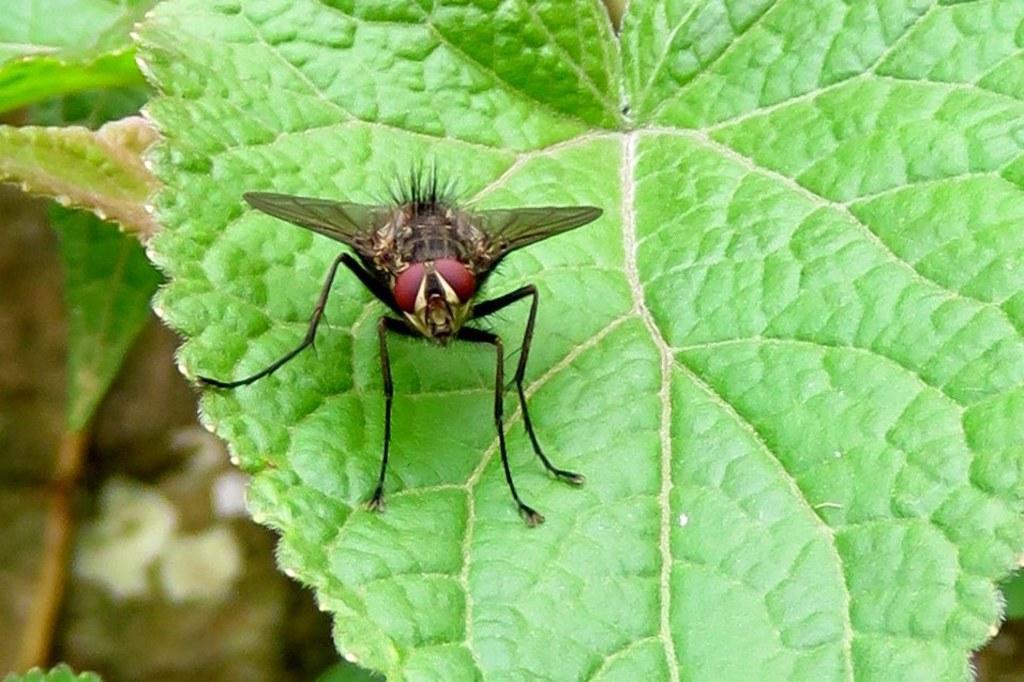Please provide a concise description of this image. In this picture I can see a fly on the leaf and I can see few leaves on the left side. 